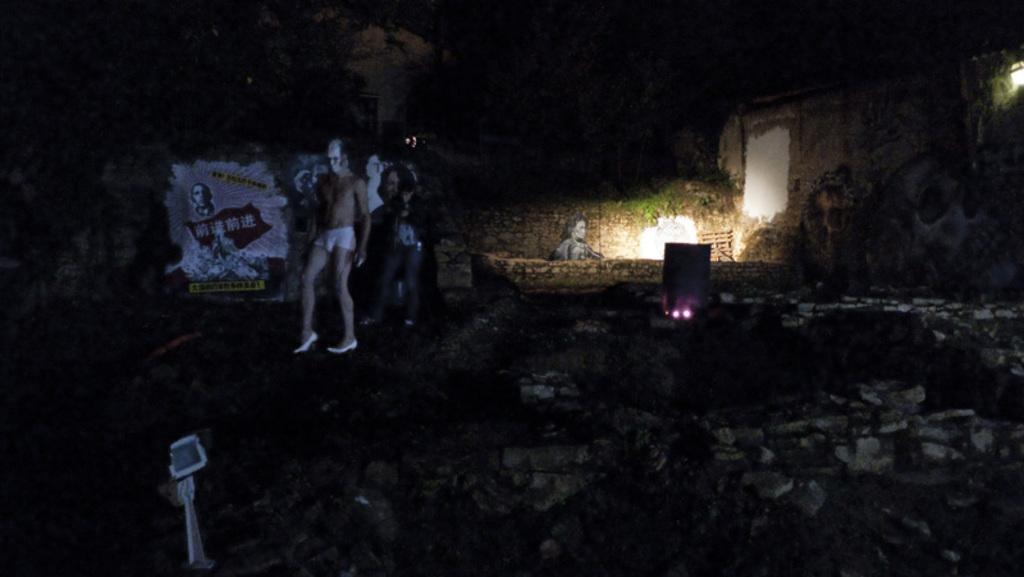In one or two sentences, can you explain what this image depicts? This is an image clicked in the dark. At the bottom of the image there is a wall. In the background I can see few people are standing. At the back there is a poster. In the background I can see a light. 